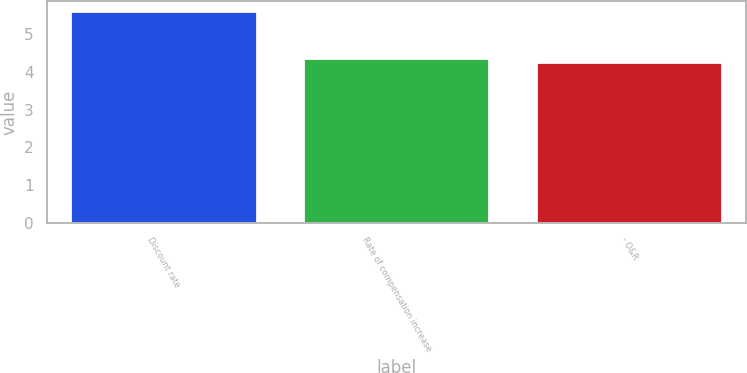<chart> <loc_0><loc_0><loc_500><loc_500><bar_chart><fcel>Discount rate<fcel>Rate of compensation increase<fcel>- O&R<nl><fcel>5.6<fcel>4.38<fcel>4.25<nl></chart> 